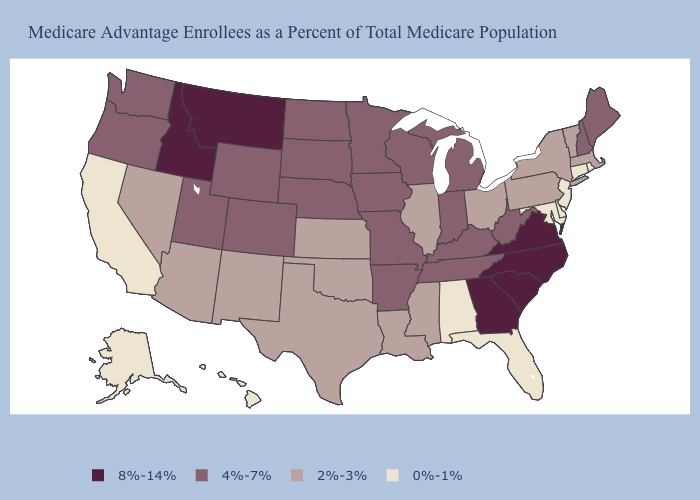What is the value of Mississippi?
Answer briefly. 2%-3%. What is the lowest value in the West?
Short answer required. 0%-1%. Name the states that have a value in the range 2%-3%?
Short answer required. Arizona, Illinois, Kansas, Louisiana, Massachusetts, Mississippi, New Mexico, Nevada, New York, Ohio, Oklahoma, Pennsylvania, Texas, Vermont. Name the states that have a value in the range 0%-1%?
Be succinct. Alaska, Alabama, California, Connecticut, Delaware, Florida, Hawaii, Maryland, New Jersey, Rhode Island. What is the value of Arizona?
Short answer required. 2%-3%. Among the states that border Ohio , which have the lowest value?
Quick response, please. Pennsylvania. What is the highest value in states that border North Dakota?
Quick response, please. 8%-14%. What is the value of Nevada?
Give a very brief answer. 2%-3%. Is the legend a continuous bar?
Short answer required. No. What is the highest value in states that border Illinois?
Be succinct. 4%-7%. Name the states that have a value in the range 0%-1%?
Give a very brief answer. Alaska, Alabama, California, Connecticut, Delaware, Florida, Hawaii, Maryland, New Jersey, Rhode Island. What is the value of Indiana?
Give a very brief answer. 4%-7%. What is the value of Oklahoma?
Short answer required. 2%-3%. What is the highest value in the Northeast ?
Answer briefly. 4%-7%. Does Wisconsin have the highest value in the MidWest?
Be succinct. Yes. 